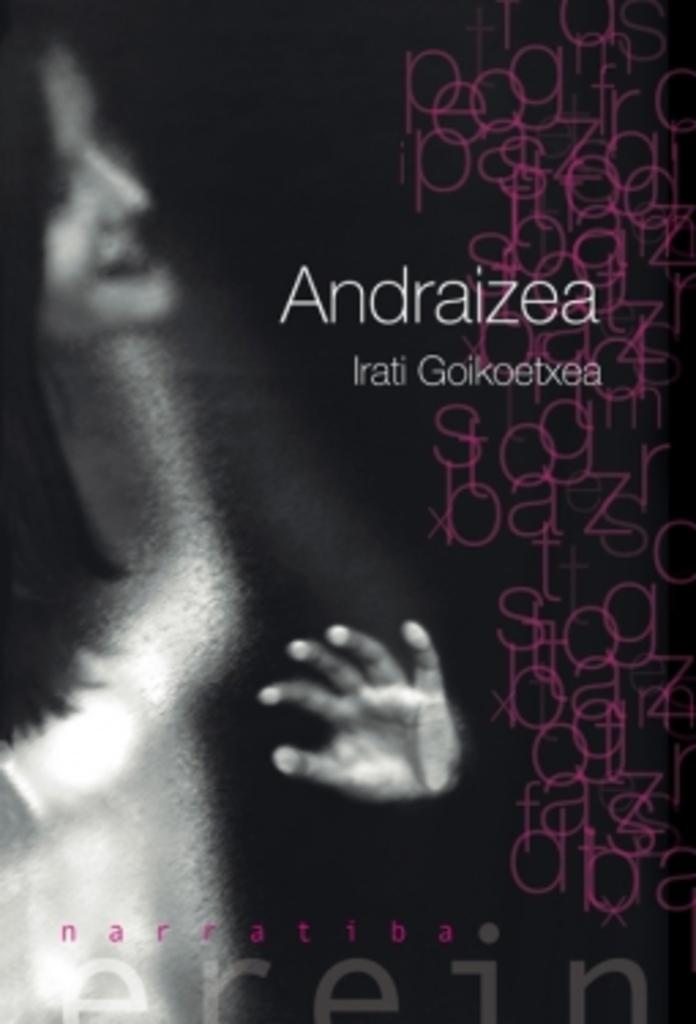<image>
Describe the image concisely. Andraizea Irati Goikoetxea on a cover by naratiba. 